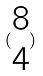<formula> <loc_0><loc_0><loc_500><loc_500>( \begin{matrix} 8 \\ 4 \end{matrix} )</formula> 